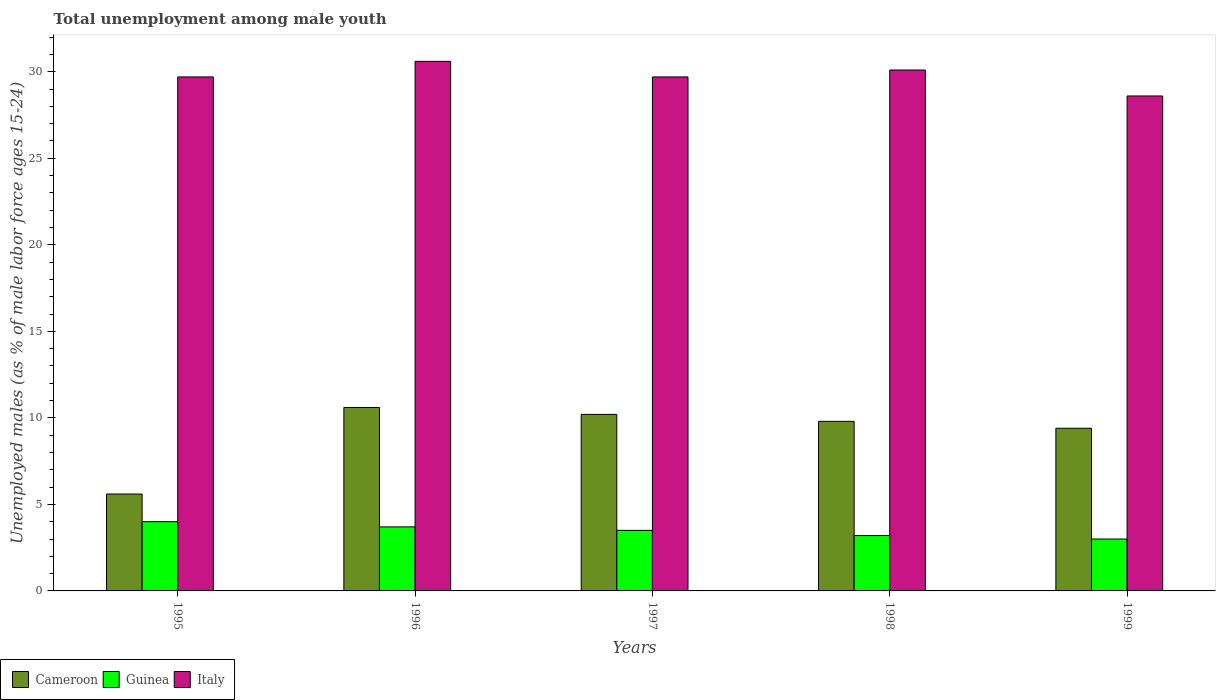How many bars are there on the 4th tick from the left?
Your answer should be very brief. 3. How many bars are there on the 1st tick from the right?
Offer a very short reply. 3. What is the label of the 3rd group of bars from the left?
Make the answer very short. 1997. In how many cases, is the number of bars for a given year not equal to the number of legend labels?
Ensure brevity in your answer.  0. What is the percentage of unemployed males in in Guinea in 1997?
Keep it short and to the point. 3.5. In which year was the percentage of unemployed males in in Cameroon minimum?
Your answer should be very brief. 1995. What is the total percentage of unemployed males in in Italy in the graph?
Offer a very short reply. 148.7. What is the difference between the percentage of unemployed males in in Cameroon in 1995 and that in 1998?
Offer a very short reply. -4.2. What is the difference between the percentage of unemployed males in in Italy in 1999 and the percentage of unemployed males in in Guinea in 1996?
Offer a very short reply. 24.9. What is the average percentage of unemployed males in in Cameroon per year?
Ensure brevity in your answer.  9.12. In the year 1995, what is the difference between the percentage of unemployed males in in Cameroon and percentage of unemployed males in in Italy?
Your answer should be very brief. -24.1. What is the ratio of the percentage of unemployed males in in Guinea in 1998 to that in 1999?
Your answer should be compact. 1.07. Is the percentage of unemployed males in in Guinea in 1996 less than that in 1997?
Provide a succinct answer. No. What is the difference between the highest and the second highest percentage of unemployed males in in Cameroon?
Keep it short and to the point. 0.4. What is the difference between the highest and the lowest percentage of unemployed males in in Cameroon?
Ensure brevity in your answer.  5. In how many years, is the percentage of unemployed males in in Cameroon greater than the average percentage of unemployed males in in Cameroon taken over all years?
Make the answer very short. 4. What does the 2nd bar from the right in 1999 represents?
Provide a short and direct response. Guinea. How many years are there in the graph?
Offer a very short reply. 5. Are the values on the major ticks of Y-axis written in scientific E-notation?
Provide a short and direct response. No. Does the graph contain grids?
Offer a terse response. No. How many legend labels are there?
Offer a terse response. 3. How are the legend labels stacked?
Your response must be concise. Horizontal. What is the title of the graph?
Ensure brevity in your answer.  Total unemployment among male youth. Does "Korea (Democratic)" appear as one of the legend labels in the graph?
Your answer should be compact. No. What is the label or title of the Y-axis?
Provide a short and direct response. Unemployed males (as % of male labor force ages 15-24). What is the Unemployed males (as % of male labor force ages 15-24) of Cameroon in 1995?
Ensure brevity in your answer.  5.6. What is the Unemployed males (as % of male labor force ages 15-24) in Italy in 1995?
Provide a succinct answer. 29.7. What is the Unemployed males (as % of male labor force ages 15-24) of Cameroon in 1996?
Ensure brevity in your answer.  10.6. What is the Unemployed males (as % of male labor force ages 15-24) in Guinea in 1996?
Give a very brief answer. 3.7. What is the Unemployed males (as % of male labor force ages 15-24) of Italy in 1996?
Keep it short and to the point. 30.6. What is the Unemployed males (as % of male labor force ages 15-24) in Cameroon in 1997?
Your answer should be compact. 10.2. What is the Unemployed males (as % of male labor force ages 15-24) of Italy in 1997?
Offer a very short reply. 29.7. What is the Unemployed males (as % of male labor force ages 15-24) of Cameroon in 1998?
Your answer should be compact. 9.8. What is the Unemployed males (as % of male labor force ages 15-24) in Guinea in 1998?
Provide a short and direct response. 3.2. What is the Unemployed males (as % of male labor force ages 15-24) in Italy in 1998?
Your answer should be very brief. 30.1. What is the Unemployed males (as % of male labor force ages 15-24) of Cameroon in 1999?
Give a very brief answer. 9.4. What is the Unemployed males (as % of male labor force ages 15-24) in Guinea in 1999?
Provide a succinct answer. 3. What is the Unemployed males (as % of male labor force ages 15-24) in Italy in 1999?
Provide a succinct answer. 28.6. Across all years, what is the maximum Unemployed males (as % of male labor force ages 15-24) in Cameroon?
Ensure brevity in your answer.  10.6. Across all years, what is the maximum Unemployed males (as % of male labor force ages 15-24) of Guinea?
Your answer should be very brief. 4. Across all years, what is the maximum Unemployed males (as % of male labor force ages 15-24) in Italy?
Offer a terse response. 30.6. Across all years, what is the minimum Unemployed males (as % of male labor force ages 15-24) of Cameroon?
Your response must be concise. 5.6. Across all years, what is the minimum Unemployed males (as % of male labor force ages 15-24) in Italy?
Keep it short and to the point. 28.6. What is the total Unemployed males (as % of male labor force ages 15-24) in Cameroon in the graph?
Provide a succinct answer. 45.6. What is the total Unemployed males (as % of male labor force ages 15-24) in Italy in the graph?
Ensure brevity in your answer.  148.7. What is the difference between the Unemployed males (as % of male labor force ages 15-24) in Guinea in 1995 and that in 1997?
Offer a terse response. 0.5. What is the difference between the Unemployed males (as % of male labor force ages 15-24) of Guinea in 1995 and that in 1998?
Make the answer very short. 0.8. What is the difference between the Unemployed males (as % of male labor force ages 15-24) of Guinea in 1995 and that in 1999?
Your answer should be compact. 1. What is the difference between the Unemployed males (as % of male labor force ages 15-24) of Cameroon in 1996 and that in 1997?
Offer a very short reply. 0.4. What is the difference between the Unemployed males (as % of male labor force ages 15-24) in Guinea in 1996 and that in 1997?
Provide a short and direct response. 0.2. What is the difference between the Unemployed males (as % of male labor force ages 15-24) of Cameroon in 1996 and that in 1998?
Offer a very short reply. 0.8. What is the difference between the Unemployed males (as % of male labor force ages 15-24) of Guinea in 1996 and that in 1998?
Offer a terse response. 0.5. What is the difference between the Unemployed males (as % of male labor force ages 15-24) in Italy in 1996 and that in 1998?
Provide a short and direct response. 0.5. What is the difference between the Unemployed males (as % of male labor force ages 15-24) of Guinea in 1997 and that in 1998?
Your answer should be compact. 0.3. What is the difference between the Unemployed males (as % of male labor force ages 15-24) of Italy in 1997 and that in 1998?
Keep it short and to the point. -0.4. What is the difference between the Unemployed males (as % of male labor force ages 15-24) of Guinea in 1997 and that in 1999?
Offer a very short reply. 0.5. What is the difference between the Unemployed males (as % of male labor force ages 15-24) in Italy in 1997 and that in 1999?
Your answer should be very brief. 1.1. What is the difference between the Unemployed males (as % of male labor force ages 15-24) of Cameroon in 1998 and that in 1999?
Give a very brief answer. 0.4. What is the difference between the Unemployed males (as % of male labor force ages 15-24) of Guinea in 1998 and that in 1999?
Your response must be concise. 0.2. What is the difference between the Unemployed males (as % of male labor force ages 15-24) of Cameroon in 1995 and the Unemployed males (as % of male labor force ages 15-24) of Guinea in 1996?
Provide a succinct answer. 1.9. What is the difference between the Unemployed males (as % of male labor force ages 15-24) in Guinea in 1995 and the Unemployed males (as % of male labor force ages 15-24) in Italy in 1996?
Your answer should be very brief. -26.6. What is the difference between the Unemployed males (as % of male labor force ages 15-24) of Cameroon in 1995 and the Unemployed males (as % of male labor force ages 15-24) of Italy in 1997?
Provide a short and direct response. -24.1. What is the difference between the Unemployed males (as % of male labor force ages 15-24) in Guinea in 1995 and the Unemployed males (as % of male labor force ages 15-24) in Italy in 1997?
Your response must be concise. -25.7. What is the difference between the Unemployed males (as % of male labor force ages 15-24) of Cameroon in 1995 and the Unemployed males (as % of male labor force ages 15-24) of Italy in 1998?
Your answer should be compact. -24.5. What is the difference between the Unemployed males (as % of male labor force ages 15-24) in Guinea in 1995 and the Unemployed males (as % of male labor force ages 15-24) in Italy in 1998?
Make the answer very short. -26.1. What is the difference between the Unemployed males (as % of male labor force ages 15-24) in Cameroon in 1995 and the Unemployed males (as % of male labor force ages 15-24) in Italy in 1999?
Your answer should be very brief. -23. What is the difference between the Unemployed males (as % of male labor force ages 15-24) in Guinea in 1995 and the Unemployed males (as % of male labor force ages 15-24) in Italy in 1999?
Keep it short and to the point. -24.6. What is the difference between the Unemployed males (as % of male labor force ages 15-24) of Cameroon in 1996 and the Unemployed males (as % of male labor force ages 15-24) of Guinea in 1997?
Your response must be concise. 7.1. What is the difference between the Unemployed males (as % of male labor force ages 15-24) of Cameroon in 1996 and the Unemployed males (as % of male labor force ages 15-24) of Italy in 1997?
Your answer should be very brief. -19.1. What is the difference between the Unemployed males (as % of male labor force ages 15-24) in Guinea in 1996 and the Unemployed males (as % of male labor force ages 15-24) in Italy in 1997?
Offer a terse response. -26. What is the difference between the Unemployed males (as % of male labor force ages 15-24) in Cameroon in 1996 and the Unemployed males (as % of male labor force ages 15-24) in Italy in 1998?
Provide a succinct answer. -19.5. What is the difference between the Unemployed males (as % of male labor force ages 15-24) of Guinea in 1996 and the Unemployed males (as % of male labor force ages 15-24) of Italy in 1998?
Provide a short and direct response. -26.4. What is the difference between the Unemployed males (as % of male labor force ages 15-24) of Cameroon in 1996 and the Unemployed males (as % of male labor force ages 15-24) of Italy in 1999?
Your answer should be compact. -18. What is the difference between the Unemployed males (as % of male labor force ages 15-24) in Guinea in 1996 and the Unemployed males (as % of male labor force ages 15-24) in Italy in 1999?
Your answer should be compact. -24.9. What is the difference between the Unemployed males (as % of male labor force ages 15-24) in Cameroon in 1997 and the Unemployed males (as % of male labor force ages 15-24) in Italy in 1998?
Your response must be concise. -19.9. What is the difference between the Unemployed males (as % of male labor force ages 15-24) in Guinea in 1997 and the Unemployed males (as % of male labor force ages 15-24) in Italy in 1998?
Give a very brief answer. -26.6. What is the difference between the Unemployed males (as % of male labor force ages 15-24) in Cameroon in 1997 and the Unemployed males (as % of male labor force ages 15-24) in Guinea in 1999?
Ensure brevity in your answer.  7.2. What is the difference between the Unemployed males (as % of male labor force ages 15-24) of Cameroon in 1997 and the Unemployed males (as % of male labor force ages 15-24) of Italy in 1999?
Your answer should be very brief. -18.4. What is the difference between the Unemployed males (as % of male labor force ages 15-24) in Guinea in 1997 and the Unemployed males (as % of male labor force ages 15-24) in Italy in 1999?
Your answer should be compact. -25.1. What is the difference between the Unemployed males (as % of male labor force ages 15-24) in Cameroon in 1998 and the Unemployed males (as % of male labor force ages 15-24) in Italy in 1999?
Ensure brevity in your answer.  -18.8. What is the difference between the Unemployed males (as % of male labor force ages 15-24) of Guinea in 1998 and the Unemployed males (as % of male labor force ages 15-24) of Italy in 1999?
Make the answer very short. -25.4. What is the average Unemployed males (as % of male labor force ages 15-24) of Cameroon per year?
Your answer should be very brief. 9.12. What is the average Unemployed males (as % of male labor force ages 15-24) in Guinea per year?
Your answer should be very brief. 3.48. What is the average Unemployed males (as % of male labor force ages 15-24) in Italy per year?
Make the answer very short. 29.74. In the year 1995, what is the difference between the Unemployed males (as % of male labor force ages 15-24) in Cameroon and Unemployed males (as % of male labor force ages 15-24) in Guinea?
Your answer should be very brief. 1.6. In the year 1995, what is the difference between the Unemployed males (as % of male labor force ages 15-24) in Cameroon and Unemployed males (as % of male labor force ages 15-24) in Italy?
Make the answer very short. -24.1. In the year 1995, what is the difference between the Unemployed males (as % of male labor force ages 15-24) of Guinea and Unemployed males (as % of male labor force ages 15-24) of Italy?
Provide a short and direct response. -25.7. In the year 1996, what is the difference between the Unemployed males (as % of male labor force ages 15-24) in Guinea and Unemployed males (as % of male labor force ages 15-24) in Italy?
Offer a very short reply. -26.9. In the year 1997, what is the difference between the Unemployed males (as % of male labor force ages 15-24) of Cameroon and Unemployed males (as % of male labor force ages 15-24) of Guinea?
Offer a terse response. 6.7. In the year 1997, what is the difference between the Unemployed males (as % of male labor force ages 15-24) of Cameroon and Unemployed males (as % of male labor force ages 15-24) of Italy?
Give a very brief answer. -19.5. In the year 1997, what is the difference between the Unemployed males (as % of male labor force ages 15-24) in Guinea and Unemployed males (as % of male labor force ages 15-24) in Italy?
Offer a terse response. -26.2. In the year 1998, what is the difference between the Unemployed males (as % of male labor force ages 15-24) in Cameroon and Unemployed males (as % of male labor force ages 15-24) in Italy?
Provide a succinct answer. -20.3. In the year 1998, what is the difference between the Unemployed males (as % of male labor force ages 15-24) of Guinea and Unemployed males (as % of male labor force ages 15-24) of Italy?
Ensure brevity in your answer.  -26.9. In the year 1999, what is the difference between the Unemployed males (as % of male labor force ages 15-24) of Cameroon and Unemployed males (as % of male labor force ages 15-24) of Guinea?
Your answer should be compact. 6.4. In the year 1999, what is the difference between the Unemployed males (as % of male labor force ages 15-24) of Cameroon and Unemployed males (as % of male labor force ages 15-24) of Italy?
Ensure brevity in your answer.  -19.2. In the year 1999, what is the difference between the Unemployed males (as % of male labor force ages 15-24) in Guinea and Unemployed males (as % of male labor force ages 15-24) in Italy?
Provide a short and direct response. -25.6. What is the ratio of the Unemployed males (as % of male labor force ages 15-24) in Cameroon in 1995 to that in 1996?
Make the answer very short. 0.53. What is the ratio of the Unemployed males (as % of male labor force ages 15-24) of Guinea in 1995 to that in 1996?
Your answer should be very brief. 1.08. What is the ratio of the Unemployed males (as % of male labor force ages 15-24) in Italy in 1995 to that in 1996?
Provide a short and direct response. 0.97. What is the ratio of the Unemployed males (as % of male labor force ages 15-24) in Cameroon in 1995 to that in 1997?
Provide a short and direct response. 0.55. What is the ratio of the Unemployed males (as % of male labor force ages 15-24) in Guinea in 1995 to that in 1997?
Provide a succinct answer. 1.14. What is the ratio of the Unemployed males (as % of male labor force ages 15-24) in Italy in 1995 to that in 1997?
Provide a short and direct response. 1. What is the ratio of the Unemployed males (as % of male labor force ages 15-24) in Italy in 1995 to that in 1998?
Give a very brief answer. 0.99. What is the ratio of the Unemployed males (as % of male labor force ages 15-24) in Cameroon in 1995 to that in 1999?
Your answer should be very brief. 0.6. What is the ratio of the Unemployed males (as % of male labor force ages 15-24) in Guinea in 1995 to that in 1999?
Offer a terse response. 1.33. What is the ratio of the Unemployed males (as % of male labor force ages 15-24) of Italy in 1995 to that in 1999?
Ensure brevity in your answer.  1.04. What is the ratio of the Unemployed males (as % of male labor force ages 15-24) in Cameroon in 1996 to that in 1997?
Offer a terse response. 1.04. What is the ratio of the Unemployed males (as % of male labor force ages 15-24) in Guinea in 1996 to that in 1997?
Give a very brief answer. 1.06. What is the ratio of the Unemployed males (as % of male labor force ages 15-24) of Italy in 1996 to that in 1997?
Offer a terse response. 1.03. What is the ratio of the Unemployed males (as % of male labor force ages 15-24) in Cameroon in 1996 to that in 1998?
Provide a short and direct response. 1.08. What is the ratio of the Unemployed males (as % of male labor force ages 15-24) in Guinea in 1996 to that in 1998?
Keep it short and to the point. 1.16. What is the ratio of the Unemployed males (as % of male labor force ages 15-24) in Italy in 1996 to that in 1998?
Offer a very short reply. 1.02. What is the ratio of the Unemployed males (as % of male labor force ages 15-24) in Cameroon in 1996 to that in 1999?
Your answer should be very brief. 1.13. What is the ratio of the Unemployed males (as % of male labor force ages 15-24) of Guinea in 1996 to that in 1999?
Offer a very short reply. 1.23. What is the ratio of the Unemployed males (as % of male labor force ages 15-24) in Italy in 1996 to that in 1999?
Ensure brevity in your answer.  1.07. What is the ratio of the Unemployed males (as % of male labor force ages 15-24) of Cameroon in 1997 to that in 1998?
Provide a succinct answer. 1.04. What is the ratio of the Unemployed males (as % of male labor force ages 15-24) in Guinea in 1997 to that in 1998?
Offer a terse response. 1.09. What is the ratio of the Unemployed males (as % of male labor force ages 15-24) in Italy in 1997 to that in 1998?
Offer a very short reply. 0.99. What is the ratio of the Unemployed males (as % of male labor force ages 15-24) in Cameroon in 1997 to that in 1999?
Offer a terse response. 1.09. What is the ratio of the Unemployed males (as % of male labor force ages 15-24) of Italy in 1997 to that in 1999?
Offer a terse response. 1.04. What is the ratio of the Unemployed males (as % of male labor force ages 15-24) in Cameroon in 1998 to that in 1999?
Provide a short and direct response. 1.04. What is the ratio of the Unemployed males (as % of male labor force ages 15-24) in Guinea in 1998 to that in 1999?
Offer a terse response. 1.07. What is the ratio of the Unemployed males (as % of male labor force ages 15-24) in Italy in 1998 to that in 1999?
Make the answer very short. 1.05. What is the difference between the highest and the second highest Unemployed males (as % of male labor force ages 15-24) in Cameroon?
Provide a short and direct response. 0.4. What is the difference between the highest and the second highest Unemployed males (as % of male labor force ages 15-24) of Guinea?
Ensure brevity in your answer.  0.3. What is the difference between the highest and the lowest Unemployed males (as % of male labor force ages 15-24) in Italy?
Your response must be concise. 2. 